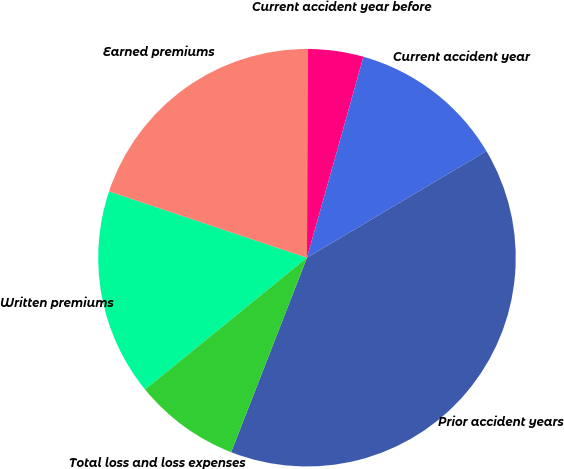Convert chart to OTSL. <chart><loc_0><loc_0><loc_500><loc_500><pie_chart><fcel>Written premiums<fcel>Earned premiums<fcel>Current accident year before<fcel>Current accident year<fcel>Prior accident years<fcel>Total loss and loss expenses<nl><fcel>16.02%<fcel>19.92%<fcel>4.3%<fcel>12.11%<fcel>39.45%<fcel>8.21%<nl></chart> 